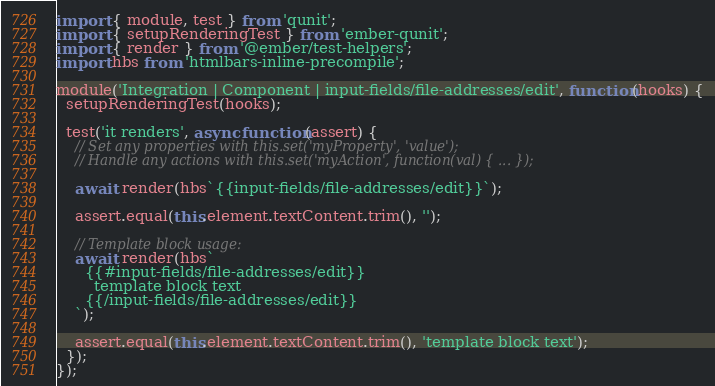<code> <loc_0><loc_0><loc_500><loc_500><_JavaScript_>import { module, test } from 'qunit';
import { setupRenderingTest } from 'ember-qunit';
import { render } from '@ember/test-helpers';
import hbs from 'htmlbars-inline-precompile';

module('Integration | Component | input-fields/file-addresses/edit', function(hooks) {
  setupRenderingTest(hooks);

  test('it renders', async function(assert) {
    // Set any properties with this.set('myProperty', 'value');
    // Handle any actions with this.set('myAction', function(val) { ... });

    await render(hbs`{{input-fields/file-addresses/edit}}`);

    assert.equal(this.element.textContent.trim(), '');

    // Template block usage:
    await render(hbs`
      {{#input-fields/file-addresses/edit}}
        template block text
      {{/input-fields/file-addresses/edit}}
    `);

    assert.equal(this.element.textContent.trim(), 'template block text');
  });
});
</code> 